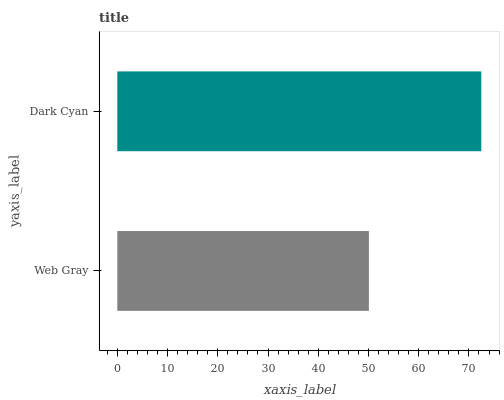Is Web Gray the minimum?
Answer yes or no. Yes. Is Dark Cyan the maximum?
Answer yes or no. Yes. Is Dark Cyan the minimum?
Answer yes or no. No. Is Dark Cyan greater than Web Gray?
Answer yes or no. Yes. Is Web Gray less than Dark Cyan?
Answer yes or no. Yes. Is Web Gray greater than Dark Cyan?
Answer yes or no. No. Is Dark Cyan less than Web Gray?
Answer yes or no. No. Is Dark Cyan the high median?
Answer yes or no. Yes. Is Web Gray the low median?
Answer yes or no. Yes. Is Web Gray the high median?
Answer yes or no. No. Is Dark Cyan the low median?
Answer yes or no. No. 